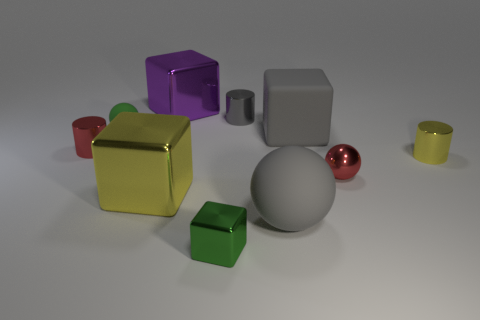Subtract all blocks. How many objects are left? 6 Subtract all small red balls. Subtract all small green shiny cubes. How many objects are left? 8 Add 1 gray metallic cylinders. How many gray metallic cylinders are left? 2 Add 1 large purple objects. How many large purple objects exist? 2 Subtract 0 brown cylinders. How many objects are left? 10 